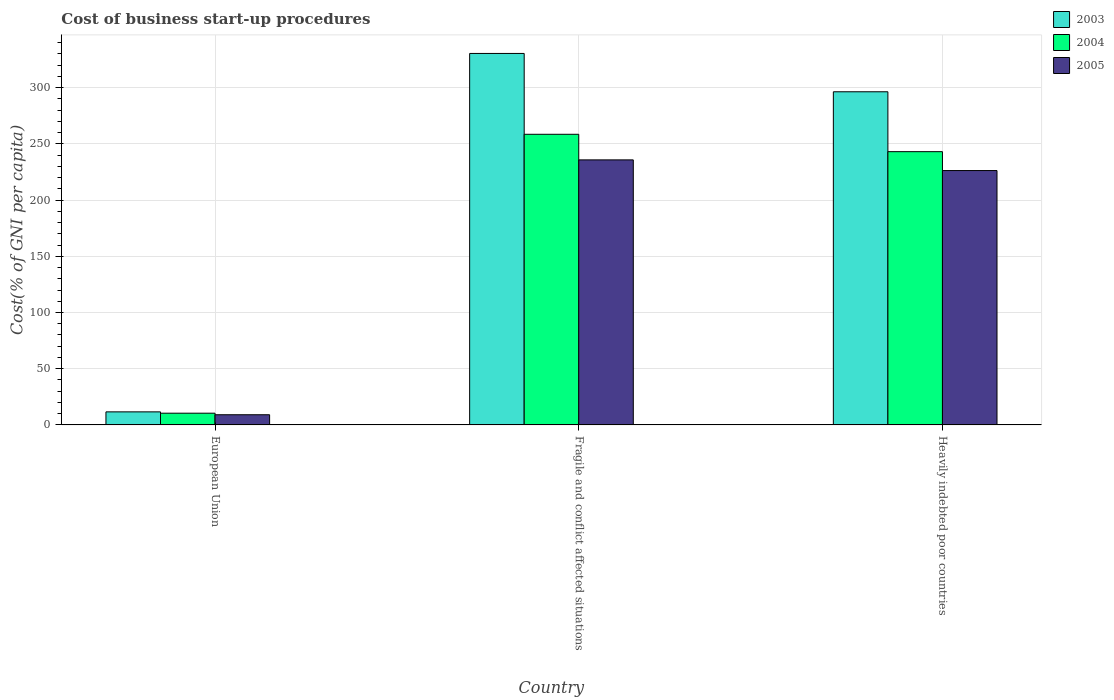How many different coloured bars are there?
Provide a short and direct response. 3. Are the number of bars per tick equal to the number of legend labels?
Ensure brevity in your answer.  Yes. How many bars are there on the 2nd tick from the left?
Provide a succinct answer. 3. What is the label of the 3rd group of bars from the left?
Provide a succinct answer. Heavily indebted poor countries. What is the cost of business start-up procedures in 2005 in Fragile and conflict affected situations?
Your answer should be compact. 235.78. Across all countries, what is the maximum cost of business start-up procedures in 2004?
Offer a very short reply. 258.54. Across all countries, what is the minimum cost of business start-up procedures in 2003?
Make the answer very short. 11.6. In which country was the cost of business start-up procedures in 2004 maximum?
Keep it short and to the point. Fragile and conflict affected situations. In which country was the cost of business start-up procedures in 2003 minimum?
Your answer should be very brief. European Union. What is the total cost of business start-up procedures in 2005 in the graph?
Provide a short and direct response. 471.12. What is the difference between the cost of business start-up procedures in 2005 in European Union and that in Heavily indebted poor countries?
Offer a very short reply. -217.23. What is the difference between the cost of business start-up procedures in 2005 in Fragile and conflict affected situations and the cost of business start-up procedures in 2004 in European Union?
Provide a short and direct response. 225.36. What is the average cost of business start-up procedures in 2004 per country?
Your answer should be very brief. 170.69. What is the difference between the cost of business start-up procedures of/in 2005 and cost of business start-up procedures of/in 2003 in Fragile and conflict affected situations?
Make the answer very short. -94.68. What is the ratio of the cost of business start-up procedures in 2003 in European Union to that in Heavily indebted poor countries?
Your answer should be very brief. 0.04. Is the difference between the cost of business start-up procedures in 2005 in European Union and Fragile and conflict affected situations greater than the difference between the cost of business start-up procedures in 2003 in European Union and Fragile and conflict affected situations?
Keep it short and to the point. Yes. What is the difference between the highest and the second highest cost of business start-up procedures in 2005?
Provide a succinct answer. -217.23. What is the difference between the highest and the lowest cost of business start-up procedures in 2005?
Make the answer very short. 226.73. In how many countries, is the cost of business start-up procedures in 2004 greater than the average cost of business start-up procedures in 2004 taken over all countries?
Your answer should be very brief. 2. What does the 2nd bar from the left in Heavily indebted poor countries represents?
Ensure brevity in your answer.  2004. Is it the case that in every country, the sum of the cost of business start-up procedures in 2004 and cost of business start-up procedures in 2003 is greater than the cost of business start-up procedures in 2005?
Keep it short and to the point. Yes. What is the difference between two consecutive major ticks on the Y-axis?
Your answer should be compact. 50. Does the graph contain any zero values?
Give a very brief answer. No. Does the graph contain grids?
Your answer should be compact. Yes. How many legend labels are there?
Offer a terse response. 3. How are the legend labels stacked?
Your answer should be compact. Vertical. What is the title of the graph?
Make the answer very short. Cost of business start-up procedures. Does "1987" appear as one of the legend labels in the graph?
Your response must be concise. No. What is the label or title of the X-axis?
Make the answer very short. Country. What is the label or title of the Y-axis?
Keep it short and to the point. Cost(% of GNI per capita). What is the Cost(% of GNI per capita) in 2003 in European Union?
Keep it short and to the point. 11.6. What is the Cost(% of GNI per capita) in 2004 in European Union?
Keep it short and to the point. 10.42. What is the Cost(% of GNI per capita) of 2005 in European Union?
Your response must be concise. 9.05. What is the Cost(% of GNI per capita) of 2003 in Fragile and conflict affected situations?
Give a very brief answer. 330.46. What is the Cost(% of GNI per capita) of 2004 in Fragile and conflict affected situations?
Your answer should be compact. 258.54. What is the Cost(% of GNI per capita) of 2005 in Fragile and conflict affected situations?
Your answer should be compact. 235.78. What is the Cost(% of GNI per capita) of 2003 in Heavily indebted poor countries?
Make the answer very short. 296.36. What is the Cost(% of GNI per capita) of 2004 in Heavily indebted poor countries?
Your answer should be compact. 243.09. What is the Cost(% of GNI per capita) in 2005 in Heavily indebted poor countries?
Provide a succinct answer. 226.29. Across all countries, what is the maximum Cost(% of GNI per capita) in 2003?
Your response must be concise. 330.46. Across all countries, what is the maximum Cost(% of GNI per capita) in 2004?
Keep it short and to the point. 258.54. Across all countries, what is the maximum Cost(% of GNI per capita) in 2005?
Ensure brevity in your answer.  235.78. Across all countries, what is the minimum Cost(% of GNI per capita) of 2003?
Ensure brevity in your answer.  11.6. Across all countries, what is the minimum Cost(% of GNI per capita) in 2004?
Ensure brevity in your answer.  10.42. Across all countries, what is the minimum Cost(% of GNI per capita) in 2005?
Ensure brevity in your answer.  9.05. What is the total Cost(% of GNI per capita) of 2003 in the graph?
Your answer should be compact. 638.43. What is the total Cost(% of GNI per capita) in 2004 in the graph?
Your answer should be very brief. 512.06. What is the total Cost(% of GNI per capita) of 2005 in the graph?
Your answer should be compact. 471.12. What is the difference between the Cost(% of GNI per capita) of 2003 in European Union and that in Fragile and conflict affected situations?
Provide a succinct answer. -318.86. What is the difference between the Cost(% of GNI per capita) of 2004 in European Union and that in Fragile and conflict affected situations?
Your response must be concise. -248.12. What is the difference between the Cost(% of GNI per capita) of 2005 in European Union and that in Fragile and conflict affected situations?
Give a very brief answer. -226.73. What is the difference between the Cost(% of GNI per capita) in 2003 in European Union and that in Heavily indebted poor countries?
Give a very brief answer. -284.76. What is the difference between the Cost(% of GNI per capita) of 2004 in European Union and that in Heavily indebted poor countries?
Ensure brevity in your answer.  -232.66. What is the difference between the Cost(% of GNI per capita) in 2005 in European Union and that in Heavily indebted poor countries?
Give a very brief answer. -217.23. What is the difference between the Cost(% of GNI per capita) in 2003 in Fragile and conflict affected situations and that in Heavily indebted poor countries?
Keep it short and to the point. 34.1. What is the difference between the Cost(% of GNI per capita) of 2004 in Fragile and conflict affected situations and that in Heavily indebted poor countries?
Give a very brief answer. 15.46. What is the difference between the Cost(% of GNI per capita) in 2005 in Fragile and conflict affected situations and that in Heavily indebted poor countries?
Keep it short and to the point. 9.5. What is the difference between the Cost(% of GNI per capita) in 2003 in European Union and the Cost(% of GNI per capita) in 2004 in Fragile and conflict affected situations?
Make the answer very short. -246.94. What is the difference between the Cost(% of GNI per capita) in 2003 in European Union and the Cost(% of GNI per capita) in 2005 in Fragile and conflict affected situations?
Provide a short and direct response. -224.18. What is the difference between the Cost(% of GNI per capita) of 2004 in European Union and the Cost(% of GNI per capita) of 2005 in Fragile and conflict affected situations?
Your answer should be compact. -225.36. What is the difference between the Cost(% of GNI per capita) of 2003 in European Union and the Cost(% of GNI per capita) of 2004 in Heavily indebted poor countries?
Ensure brevity in your answer.  -231.48. What is the difference between the Cost(% of GNI per capita) of 2003 in European Union and the Cost(% of GNI per capita) of 2005 in Heavily indebted poor countries?
Make the answer very short. -214.68. What is the difference between the Cost(% of GNI per capita) in 2004 in European Union and the Cost(% of GNI per capita) in 2005 in Heavily indebted poor countries?
Your answer should be very brief. -215.86. What is the difference between the Cost(% of GNI per capita) of 2003 in Fragile and conflict affected situations and the Cost(% of GNI per capita) of 2004 in Heavily indebted poor countries?
Make the answer very short. 87.37. What is the difference between the Cost(% of GNI per capita) in 2003 in Fragile and conflict affected situations and the Cost(% of GNI per capita) in 2005 in Heavily indebted poor countries?
Provide a succinct answer. 104.18. What is the difference between the Cost(% of GNI per capita) of 2004 in Fragile and conflict affected situations and the Cost(% of GNI per capita) of 2005 in Heavily indebted poor countries?
Your answer should be very brief. 32.26. What is the average Cost(% of GNI per capita) of 2003 per country?
Keep it short and to the point. 212.81. What is the average Cost(% of GNI per capita) of 2004 per country?
Provide a short and direct response. 170.69. What is the average Cost(% of GNI per capita) in 2005 per country?
Keep it short and to the point. 157.04. What is the difference between the Cost(% of GNI per capita) in 2003 and Cost(% of GNI per capita) in 2004 in European Union?
Make the answer very short. 1.18. What is the difference between the Cost(% of GNI per capita) of 2003 and Cost(% of GNI per capita) of 2005 in European Union?
Ensure brevity in your answer.  2.55. What is the difference between the Cost(% of GNI per capita) in 2004 and Cost(% of GNI per capita) in 2005 in European Union?
Provide a short and direct response. 1.37. What is the difference between the Cost(% of GNI per capita) in 2003 and Cost(% of GNI per capita) in 2004 in Fragile and conflict affected situations?
Your answer should be very brief. 71.92. What is the difference between the Cost(% of GNI per capita) in 2003 and Cost(% of GNI per capita) in 2005 in Fragile and conflict affected situations?
Offer a terse response. 94.68. What is the difference between the Cost(% of GNI per capita) in 2004 and Cost(% of GNI per capita) in 2005 in Fragile and conflict affected situations?
Provide a succinct answer. 22.76. What is the difference between the Cost(% of GNI per capita) of 2003 and Cost(% of GNI per capita) of 2004 in Heavily indebted poor countries?
Your answer should be very brief. 53.27. What is the difference between the Cost(% of GNI per capita) in 2003 and Cost(% of GNI per capita) in 2005 in Heavily indebted poor countries?
Your answer should be very brief. 70.08. What is the difference between the Cost(% of GNI per capita) in 2004 and Cost(% of GNI per capita) in 2005 in Heavily indebted poor countries?
Your answer should be compact. 16.8. What is the ratio of the Cost(% of GNI per capita) of 2003 in European Union to that in Fragile and conflict affected situations?
Your answer should be compact. 0.04. What is the ratio of the Cost(% of GNI per capita) in 2004 in European Union to that in Fragile and conflict affected situations?
Your answer should be very brief. 0.04. What is the ratio of the Cost(% of GNI per capita) in 2005 in European Union to that in Fragile and conflict affected situations?
Your answer should be compact. 0.04. What is the ratio of the Cost(% of GNI per capita) in 2003 in European Union to that in Heavily indebted poor countries?
Your response must be concise. 0.04. What is the ratio of the Cost(% of GNI per capita) in 2004 in European Union to that in Heavily indebted poor countries?
Provide a succinct answer. 0.04. What is the ratio of the Cost(% of GNI per capita) of 2003 in Fragile and conflict affected situations to that in Heavily indebted poor countries?
Your answer should be very brief. 1.12. What is the ratio of the Cost(% of GNI per capita) of 2004 in Fragile and conflict affected situations to that in Heavily indebted poor countries?
Provide a short and direct response. 1.06. What is the ratio of the Cost(% of GNI per capita) in 2005 in Fragile and conflict affected situations to that in Heavily indebted poor countries?
Provide a short and direct response. 1.04. What is the difference between the highest and the second highest Cost(% of GNI per capita) in 2003?
Your answer should be very brief. 34.1. What is the difference between the highest and the second highest Cost(% of GNI per capita) of 2004?
Your answer should be compact. 15.46. What is the difference between the highest and the second highest Cost(% of GNI per capita) in 2005?
Provide a succinct answer. 9.5. What is the difference between the highest and the lowest Cost(% of GNI per capita) of 2003?
Offer a very short reply. 318.86. What is the difference between the highest and the lowest Cost(% of GNI per capita) of 2004?
Offer a terse response. 248.12. What is the difference between the highest and the lowest Cost(% of GNI per capita) in 2005?
Offer a terse response. 226.73. 